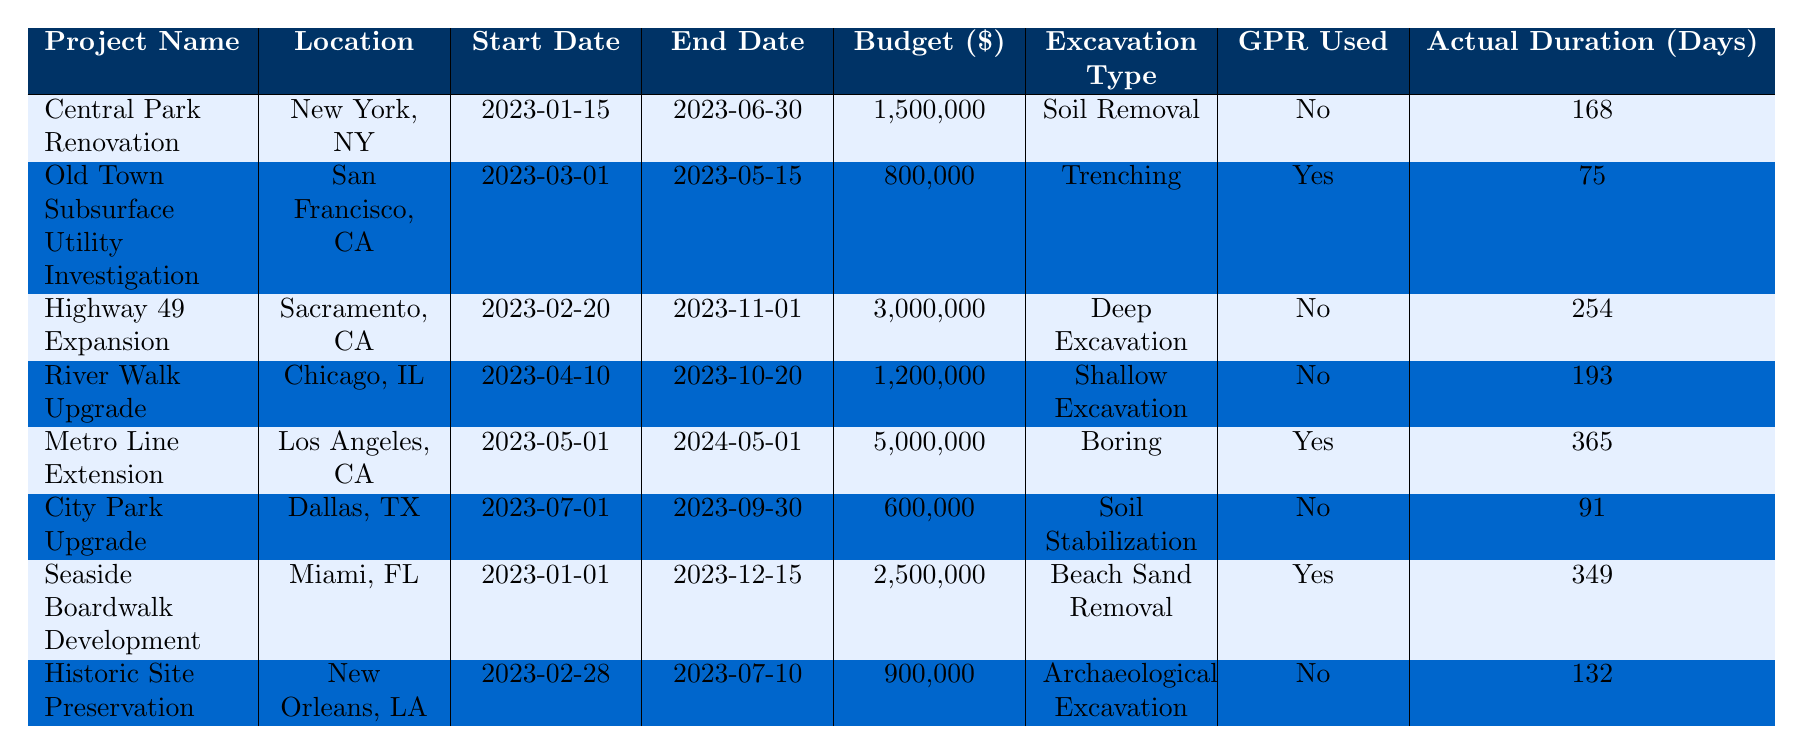What is the budget allocated for the "Metro Line Extension" project? The budget for the "Metro Line Extension" project is listed directly in the table under the Budget column. It shows $5,000,000.
Answer: $5,000,000 Which project used Ground Penetrating Radar (GPR)? The table indicates whether GPR was used in the GPR Used column. The projects "Old Town Subsurface Utility Investigation," "Metro Line Extension," and "Seaside Boardwalk Development" all indicate "Yes" for GPR used.
Answer: Old Town Subsurface Utility Investigation, Metro Line Extension, Seaside Boardwalk Development What is the total budget for projects that did not use GPR? We identify the projects that did not use GPR: "Central Park Renovation" ($1,500,000), "Highway 49 Expansion" ($3,000,000), "River Walk Upgrade" ($1,200,000), "City Park Upgrade" ($600,000), and "Historic Site Preservation" ($900,000). Adding these gives $1,500,000 + $3,000,000 + $1,200,000 + $600,000 + $900,000 = $7,200,000.
Answer: $7,200,000 What is the actual duration of the "Highway 49 Expansion" project? The actual duration of the "Highway 49 Expansion" project is found under the Actual Duration column for that project, which shows 254 days.
Answer: 254 days Did the "Seaside Boardwalk Development" project come under budget? To check if it came under budget, we compare the Budget ($2,500,000) with the Budget Used ($2,400,000). Since $2,400,000 is less than $2,500,000, it indicates that it came under budget.
Answer: Yes What project had the longest actual duration, and what was it? First, we compare the Actual Duration for all projects. "Metro Line Extension" with 365 days has the longest duration compared to others.
Answer: Metro Line Extension, 365 days What is the average budget among all projects using GPR? The GPR projects are "Old Town Subsurface Utility Investigation" ($800,000), "Metro Line Extension" ($5,000,000), and "Seaside Boardwalk Development" ($2,500,000). Summing these budgets gives $800,000 + $5,000,000 + $2,500,000 = $8,300,000. With 3 projects, the average is $8,300,000 / 3 = $2,766,666.67.
Answer: $2,766,666.67 Which project had the least budget expenditure relative to its budget, and what percentage was used? To find this, we calculate the percentage used for each project as (Budget Used / Budget) * 100. The project with the least percentage is the "Old Town Subsurface Utility Investigation" with (500,000 / 800,000) * 100 = 62.5%.
Answer: Old Town Subsurface Utility Investigation, 62.5% Which location has the highest budget allocation for excavation projects? We review the budgets for all projects in each location. "Metro Line Extension" has the highest budget of $5,000,000 for Los Angeles, indicating it is the highest allocation.
Answer: Los Angeles, $5,000,000 Is it true that all the projects scheduled to be completed in 2023 used Ground Penetrating Radar? To verify this, we check the End Dates for projects in the year 2023 and cross-examine the GPR usage. The projects "Central Park Renovation," "Highway 49 Expansion," "River Walk Upgrade," "City Park Upgrade," and "Historic Site Preservation" did not use GPR, so the statement is false.
Answer: No 